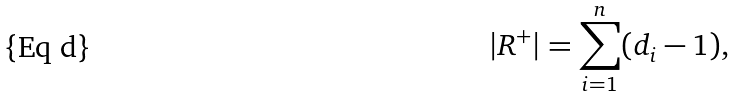Convert formula to latex. <formula><loc_0><loc_0><loc_500><loc_500>| R ^ { + } | = \sum _ { i = 1 } ^ { n } ( d _ { i } - 1 ) ,</formula> 